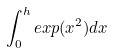<formula> <loc_0><loc_0><loc_500><loc_500>\int _ { 0 } ^ { h } e x p ( x ^ { 2 } ) d x</formula> 